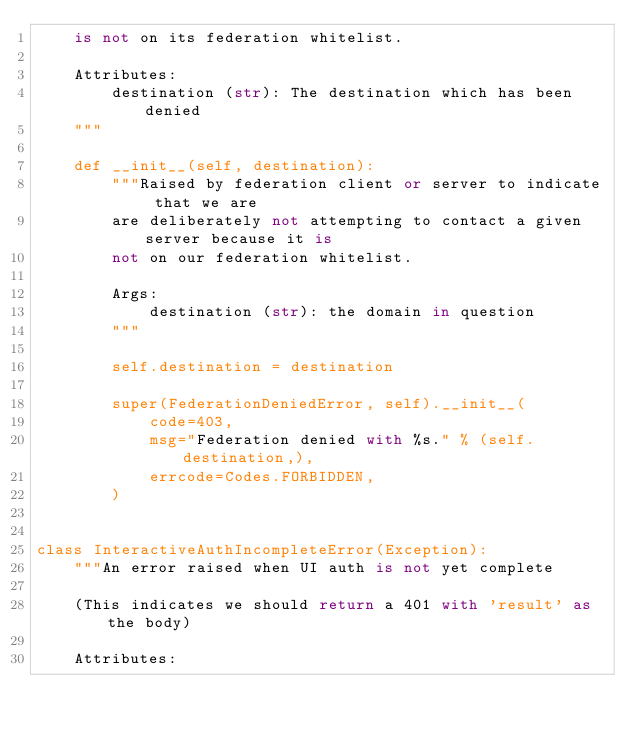<code> <loc_0><loc_0><loc_500><loc_500><_Python_>    is not on its federation whitelist.

    Attributes:
        destination (str): The destination which has been denied
    """

    def __init__(self, destination):
        """Raised by federation client or server to indicate that we are
        are deliberately not attempting to contact a given server because it is
        not on our federation whitelist.

        Args:
            destination (str): the domain in question
        """

        self.destination = destination

        super(FederationDeniedError, self).__init__(
            code=403,
            msg="Federation denied with %s." % (self.destination,),
            errcode=Codes.FORBIDDEN,
        )


class InteractiveAuthIncompleteError(Exception):
    """An error raised when UI auth is not yet complete

    (This indicates we should return a 401 with 'result' as the body)

    Attributes:</code> 